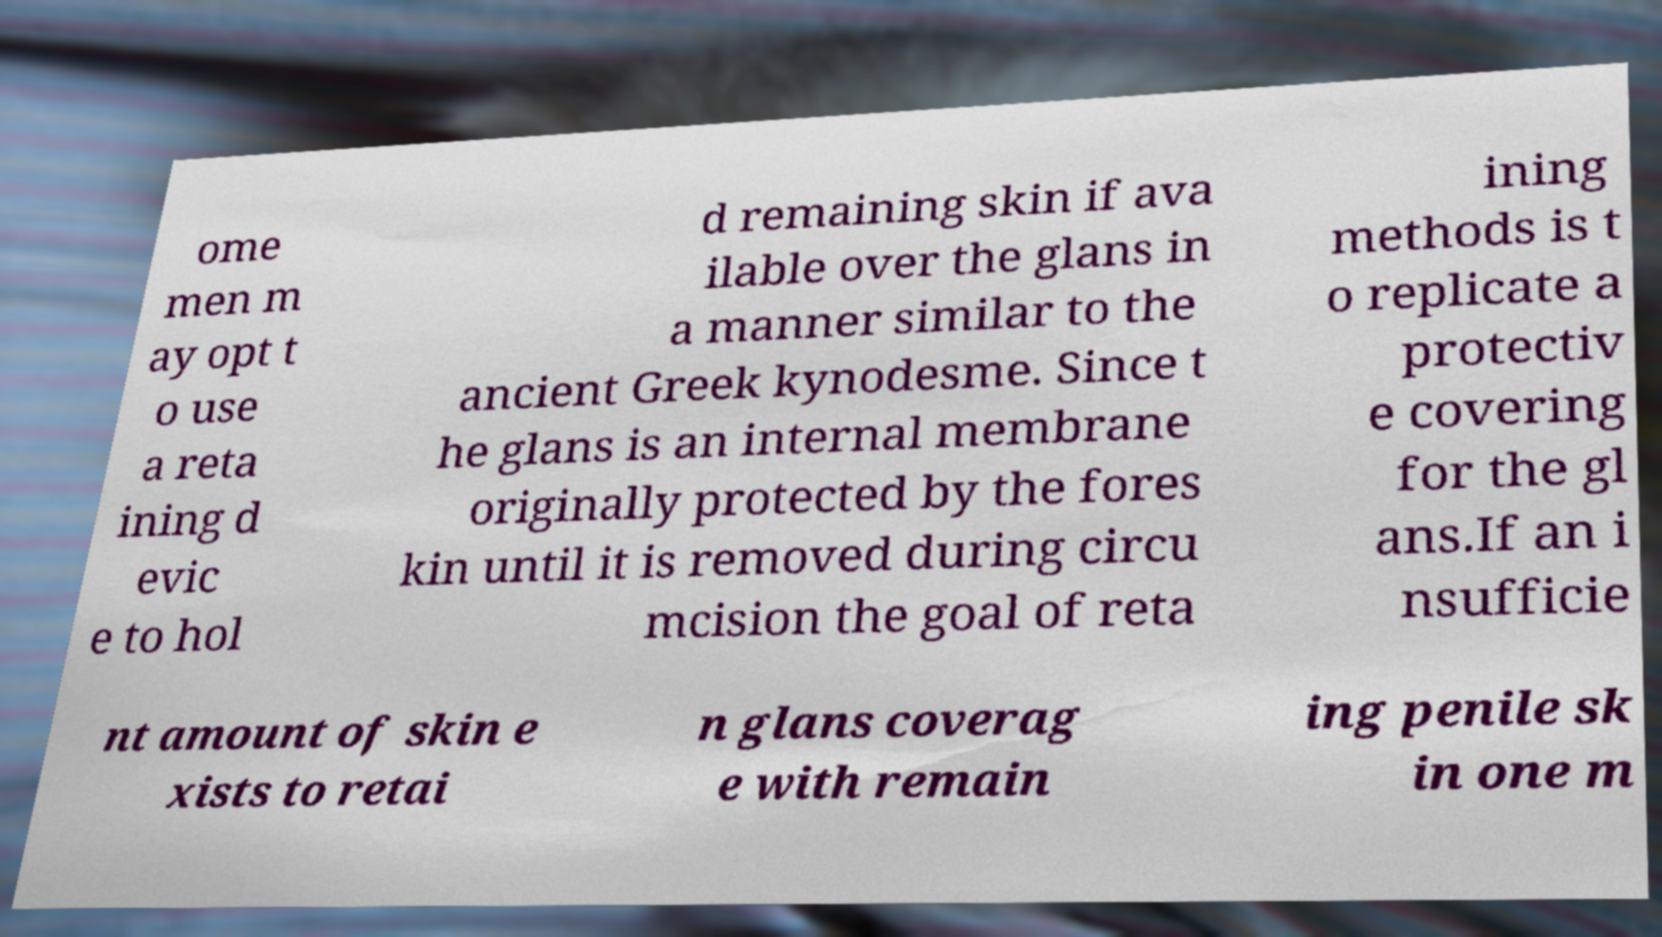Please identify and transcribe the text found in this image. ome men m ay opt t o use a reta ining d evic e to hol d remaining skin if ava ilable over the glans in a manner similar to the ancient Greek kynodesme. Since t he glans is an internal membrane originally protected by the fores kin until it is removed during circu mcision the goal of reta ining methods is t o replicate a protectiv e covering for the gl ans.If an i nsufficie nt amount of skin e xists to retai n glans coverag e with remain ing penile sk in one m 